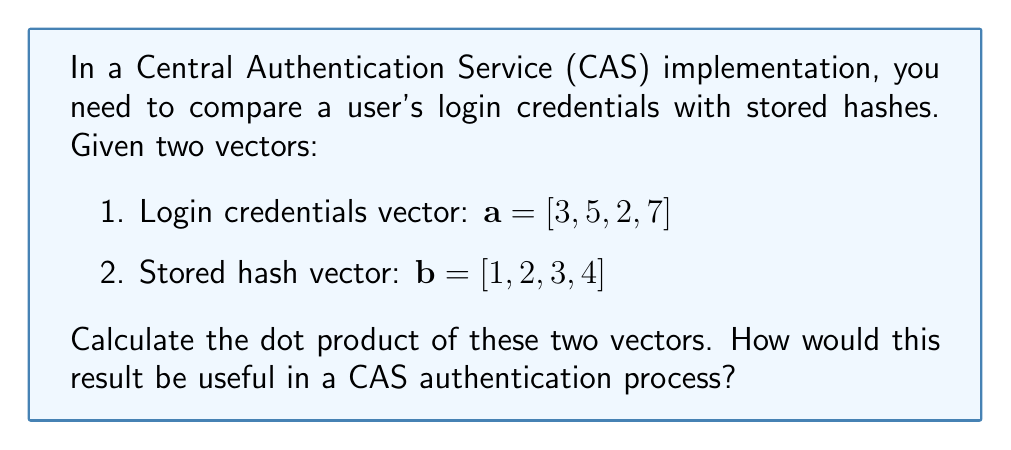Help me with this question. To calculate the dot product of two vectors, we multiply corresponding components and sum the results. For vectors $\mathbf{a} = [a_1, a_2, a_3, a_4]$ and $\mathbf{b} = [b_1, b_2, b_3, b_4]$, the dot product is given by:

$$\mathbf{a} \cdot \mathbf{b} = a_1b_1 + a_2b_2 + a_3b_3 + a_4b_4$$

For the given vectors:

$$\begin{align}
\mathbf{a} \cdot \mathbf{b} &= (3 \times 1) + (5 \times 2) + (2 \times 3) + (7 \times 4) \\
&= 3 + 10 + 6 + 28 \\
&= 47
\end{align}$$

In a CAS authentication process, this dot product calculation could be used as part of a similarity measure between the input credentials and stored hashes. A higher dot product value might indicate a closer match, although in practice, more sophisticated cryptographic hash functions and comparison methods would be used for secure authentication. This simple dot product example serves to illustrate the concept of comparing two vectors in the context of credential verification.
Answer: The dot product of the two vectors is 47. 